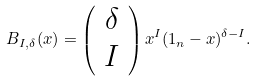Convert formula to latex. <formula><loc_0><loc_0><loc_500><loc_500>B _ { I , \delta } ( x ) = \left ( \begin{array} { c } \delta \\ I \end{array} \right ) x ^ { I } ( 1 _ { n } - x ) ^ { \delta - I } .</formula> 